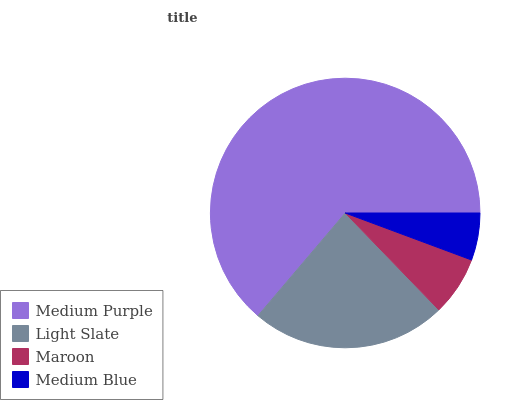Is Medium Blue the minimum?
Answer yes or no. Yes. Is Medium Purple the maximum?
Answer yes or no. Yes. Is Light Slate the minimum?
Answer yes or no. No. Is Light Slate the maximum?
Answer yes or no. No. Is Medium Purple greater than Light Slate?
Answer yes or no. Yes. Is Light Slate less than Medium Purple?
Answer yes or no. Yes. Is Light Slate greater than Medium Purple?
Answer yes or no. No. Is Medium Purple less than Light Slate?
Answer yes or no. No. Is Light Slate the high median?
Answer yes or no. Yes. Is Maroon the low median?
Answer yes or no. Yes. Is Medium Blue the high median?
Answer yes or no. No. Is Light Slate the low median?
Answer yes or no. No. 